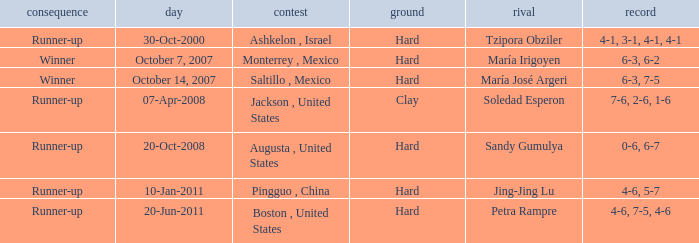Which tournament was held on October 14, 2007? Saltillo , Mexico. 